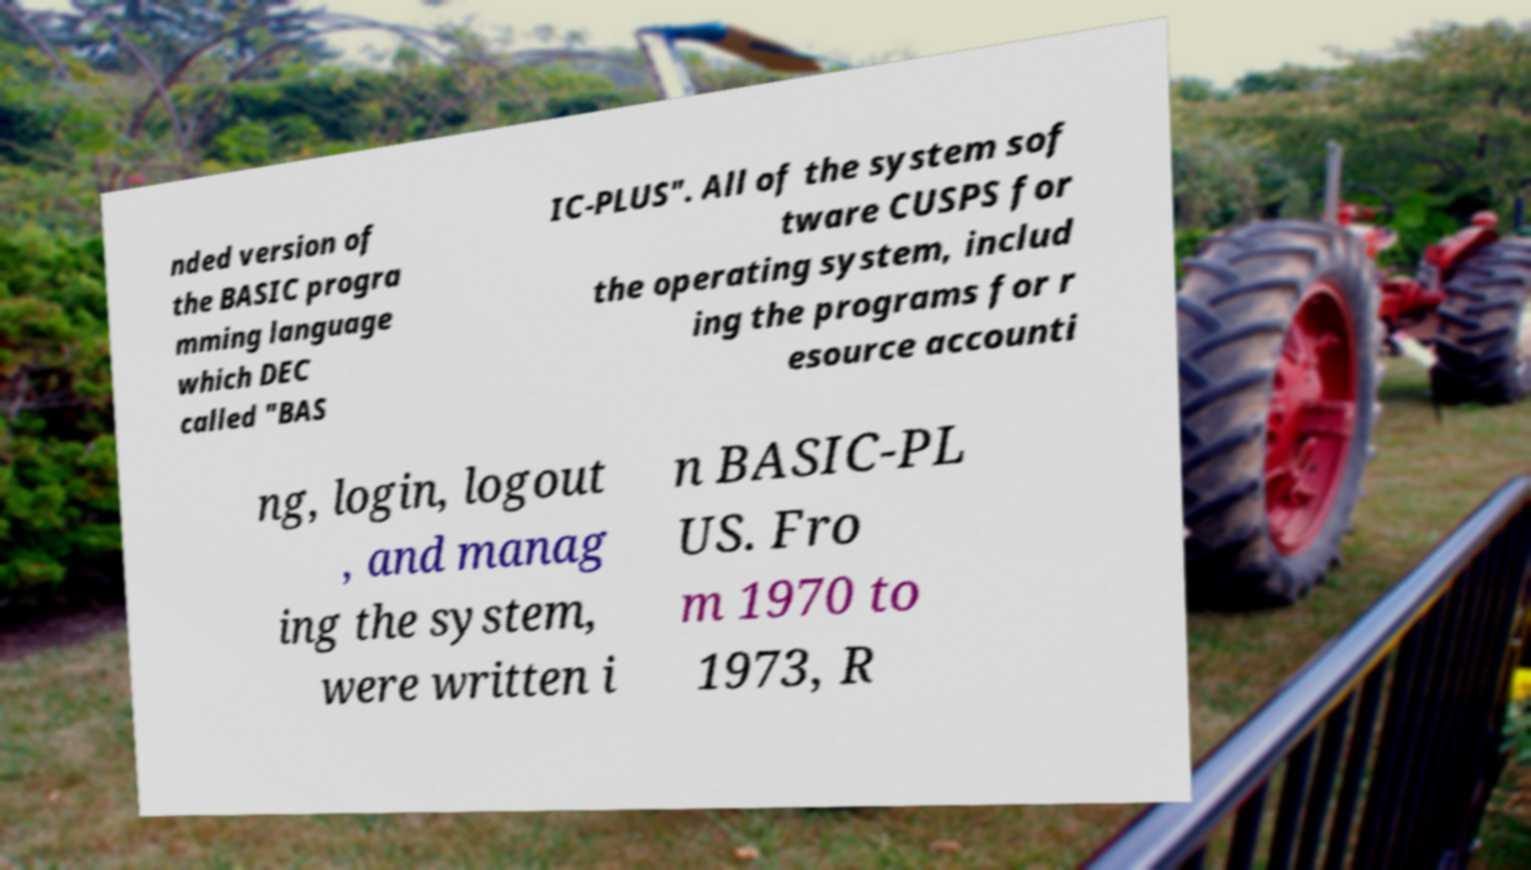Could you assist in decoding the text presented in this image and type it out clearly? nded version of the BASIC progra mming language which DEC called "BAS IC-PLUS". All of the system sof tware CUSPS for the operating system, includ ing the programs for r esource accounti ng, login, logout , and manag ing the system, were written i n BASIC-PL US. Fro m 1970 to 1973, R 